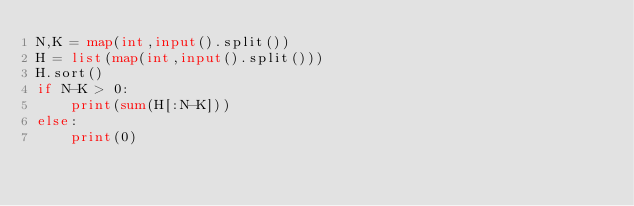<code> <loc_0><loc_0><loc_500><loc_500><_Python_>N,K = map(int,input().split())
H = list(map(int,input().split()))
H.sort()
if N-K > 0:
    print(sum(H[:N-K]))
else:
    print(0)</code> 